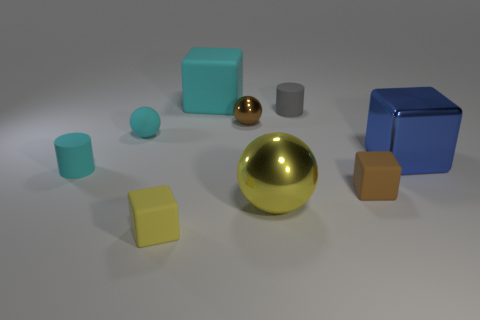Is there any other thing of the same color as the large metallic cube?
Give a very brief answer. No. What material is the object that is to the left of the tiny shiny sphere and behind the tiny metal sphere?
Your response must be concise. Rubber. There is a metal sphere that is behind the brown matte thing; is its size the same as the cyan rubber ball?
Offer a very short reply. Yes. The small yellow object has what shape?
Provide a short and direct response. Cube. What number of other things are the same shape as the small brown shiny object?
Your response must be concise. 2. How many things are in front of the tiny brown rubber object and to the right of the small yellow block?
Keep it short and to the point. 1. The big matte object has what color?
Offer a very short reply. Cyan. Is there a tiny gray cylinder made of the same material as the small yellow thing?
Ensure brevity in your answer.  Yes. Are there any shiny cubes that are on the left side of the matte cylinder to the right of the rubber cube behind the blue object?
Provide a short and direct response. No. There is a rubber sphere; are there any large objects behind it?
Give a very brief answer. Yes. 